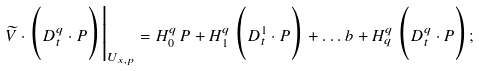Convert formula to latex. <formula><loc_0><loc_0><loc_500><loc_500>\widetilde { V } \cdot \Big ( D _ { t } ^ { q } \cdot P \Big ) \Big | _ { U _ { x , p } } = H _ { 0 } ^ { q } \, P + H _ { 1 } ^ { q } \, \Big ( D _ { t } ^ { 1 } \cdot P \Big ) + \dots b + H _ { q } ^ { q } \, \Big ( D _ { t } ^ { q } \cdot P \Big ) ;</formula> 